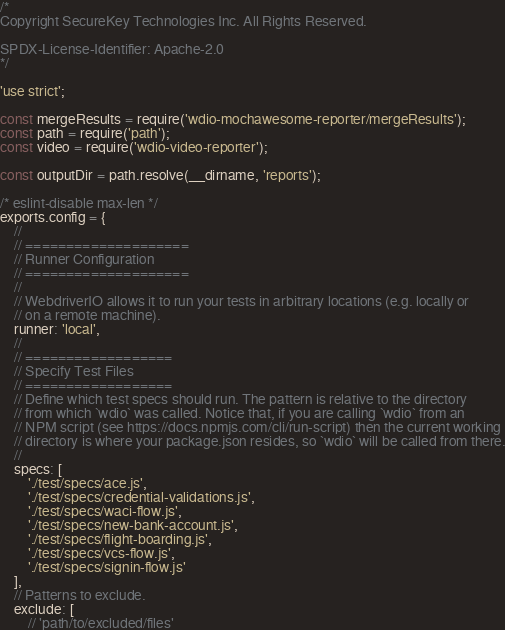Convert code to text. <code><loc_0><loc_0><loc_500><loc_500><_JavaScript_>/*
Copyright SecureKey Technologies Inc. All Rights Reserved.

SPDX-License-Identifier: Apache-2.0
*/

'use strict';

const mergeResults = require('wdio-mochawesome-reporter/mergeResults');
const path = require('path');
const video = require('wdio-video-reporter');

const outputDir = path.resolve(__dirname, 'reports');

/* eslint-disable max-len */
exports.config = {
    //
    // ====================
    // Runner Configuration
    // ====================
    //
    // WebdriverIO allows it to run your tests in arbitrary locations (e.g. locally or
    // on a remote machine).
    runner: 'local',
    //
    // ==================
    // Specify Test Files
    // ==================
    // Define which test specs should run. The pattern is relative to the directory
    // from which `wdio` was called. Notice that, if you are calling `wdio` from an
    // NPM script (see https://docs.npmjs.com/cli/run-script) then the current working
    // directory is where your package.json resides, so `wdio` will be called from there.
    //
    specs: [
        './test/specs/ace.js',
        './test/specs/credential-validations.js',
        './test/specs/waci-flow.js',
        './test/specs/new-bank-account.js',
        './test/specs/flight-boarding.js',
        './test/specs/vcs-flow.js',
        './test/specs/signin-flow.js'
    ],
    // Patterns to exclude.
    exclude: [
        // 'path/to/excluded/files'</code> 